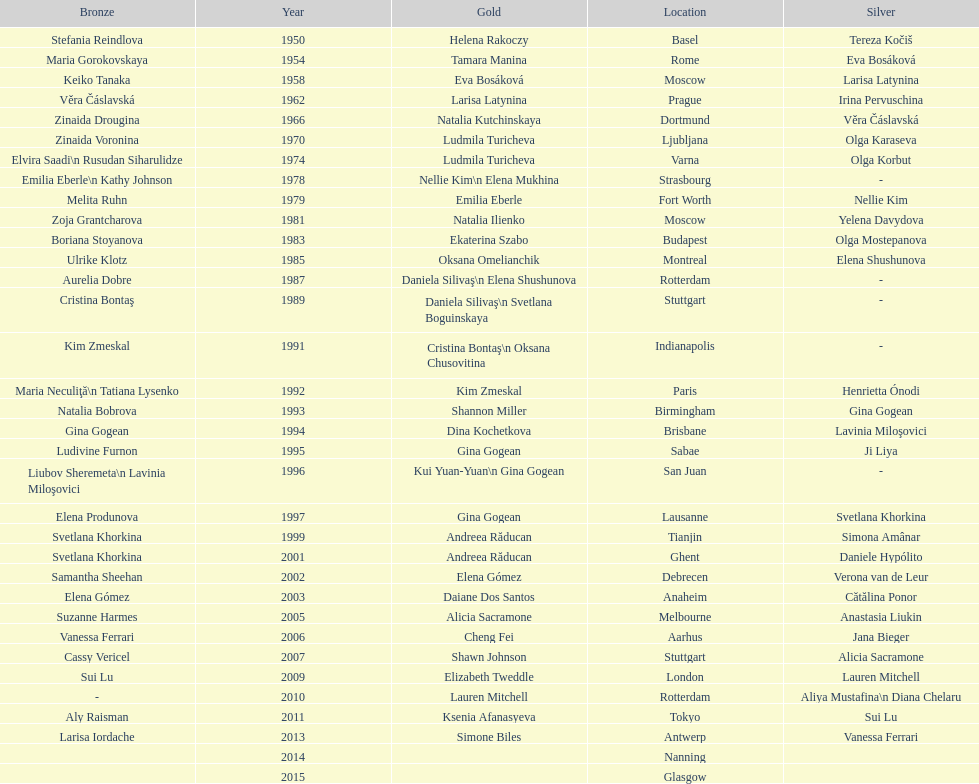Where did the world artistic gymnastics take place before san juan? Sabae. 